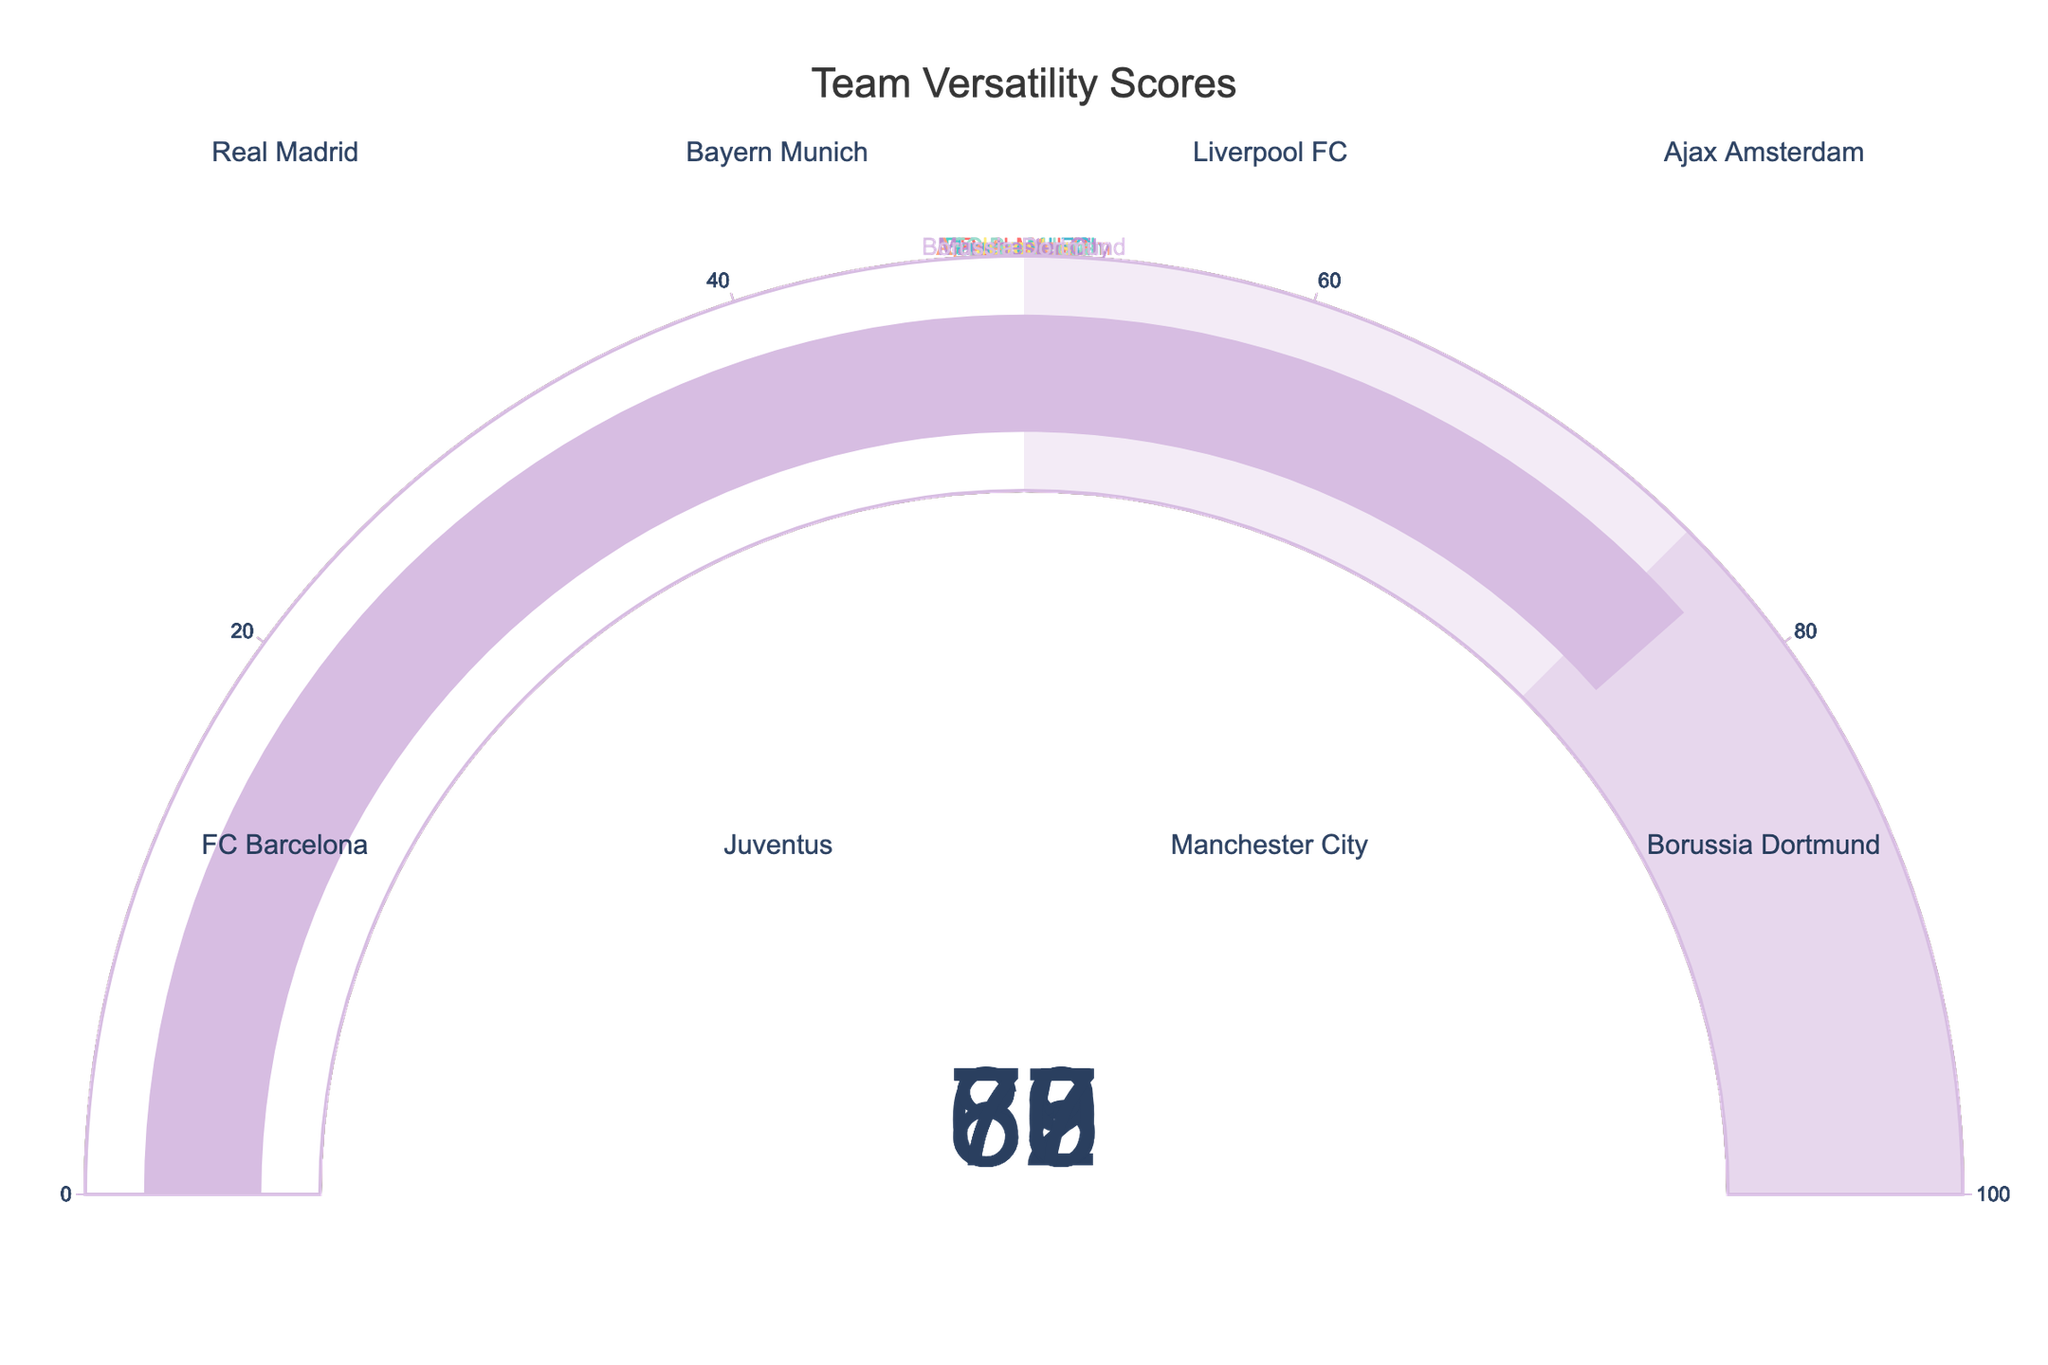What is the title of the figure? The title of the figure is mentioned at the top center of the chart. We can see it reads "Team Versatility Scores".
Answer: Team Versatility Scores Which team has the highest versatility score? Looking at the gauges, Ajax Amsterdam has the highest versatility score. The gauge for Ajax Amsterdam shows a score of 85.
Answer: Ajax Amsterdam What is the versatility score of Barcelona? Referring to the gauge chart for FC Barcelona, it shows a versatility score of 73.
Answer: 73 What is the average versatility score of all teams? First, find all the scores: 78, 82, 75, 85, 73, 69, 80, 77. Sum them up to get 619, then divide by the number of teams (8). The average score = 619/8 = 77.375.
Answer: 77.375 How much higher is Bayern Munich's versatility score compared to Juventus? The gauge for Bayern Munich shows 82 and for Juventus, it shows 69. The difference is 82 - 69 = 13.
Answer: 13 Which team has the lowest versatility score? The gauge for Juventus shows the lowest versatility score among all the teams, which is 69.
Answer: Juventus What is the range of the versatility scores in the figure? The highest score is 85 (Ajax Amsterdam) and the lowest is 69 (Juventus). The range is 85 - 69 = 16.
Answer: 16 How many teams have a versatility score of 80 or above? By inspecting all the gauges, Bayern Munich, Ajax Amsterdam, and Manchester City have scores of 80 or above. That's a total of 3 teams.
Answer: 3 If you combine the versatility scores of Liverpool FC and Borussia Dortmund, what is the total? Liverpool FC has a score of 75 and Borussia Dortmund has a score of 77. Their combined total is 75 + 77 = 152.
Answer: 152 What is the median versatility score of the teams? First, list the scores in ascending order: 69, 73, 75, 77, 78, 80, 82, 85. Since there are 8 scores, the median will be the average of the 4th and 5th scores, i.e., (77 + 78) / 2 = 77.5.
Answer: 77.5 